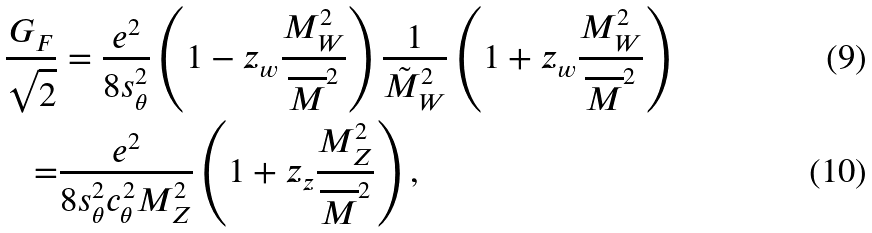<formula> <loc_0><loc_0><loc_500><loc_500>\frac { G _ { F } } { \sqrt { 2 } } & = \frac { e ^ { 2 } } { 8 s _ { \theta } ^ { 2 } } \left ( 1 - z _ { w } \frac { M _ { W } ^ { 2 } } { \overline { M } ^ { 2 } } \right ) \frac { 1 } { { \tilde { M } } _ { W } ^ { 2 } } \left ( 1 + z _ { w } \frac { M _ { W } ^ { 2 } } { \overline { M } ^ { 2 } } \right ) \\ = & \frac { e ^ { 2 } } { 8 s _ { \theta } ^ { 2 } c _ { \theta } ^ { 2 } M _ { Z } ^ { 2 } } \left ( 1 + z _ { z } \frac { M _ { Z } ^ { 2 } } { \overline { M } ^ { 2 } } \right ) ,</formula> 